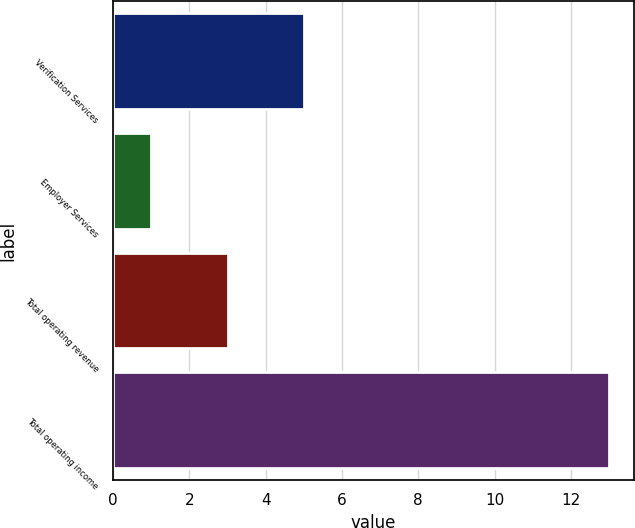Convert chart. <chart><loc_0><loc_0><loc_500><loc_500><bar_chart><fcel>Verification Services<fcel>Employer Services<fcel>Total operating revenue<fcel>Total operating income<nl><fcel>5<fcel>1<fcel>3<fcel>13<nl></chart> 